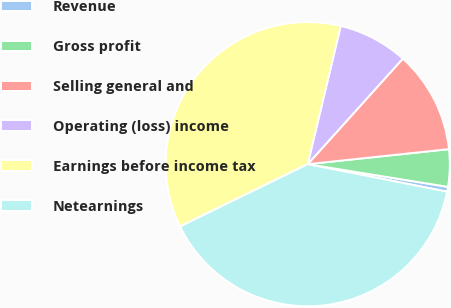<chart> <loc_0><loc_0><loc_500><loc_500><pie_chart><fcel>Revenue<fcel>Gross profit<fcel>Selling general and<fcel>Operating (loss) income<fcel>Earnings before income tax<fcel>Netearnings<nl><fcel>0.55%<fcel>4.24%<fcel>11.64%<fcel>7.94%<fcel>35.96%<fcel>39.66%<nl></chart> 